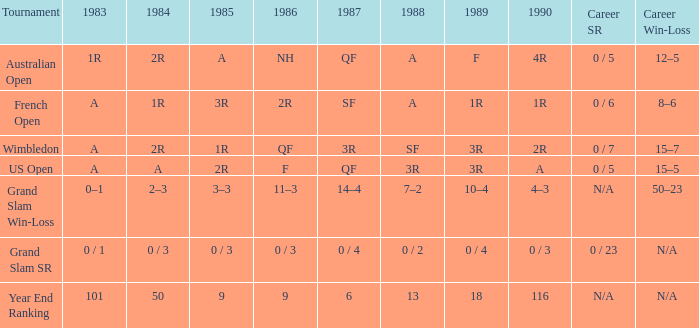What is the 1987 results when the results of 1989 is 3R, and the 1986 results is F? QF. 